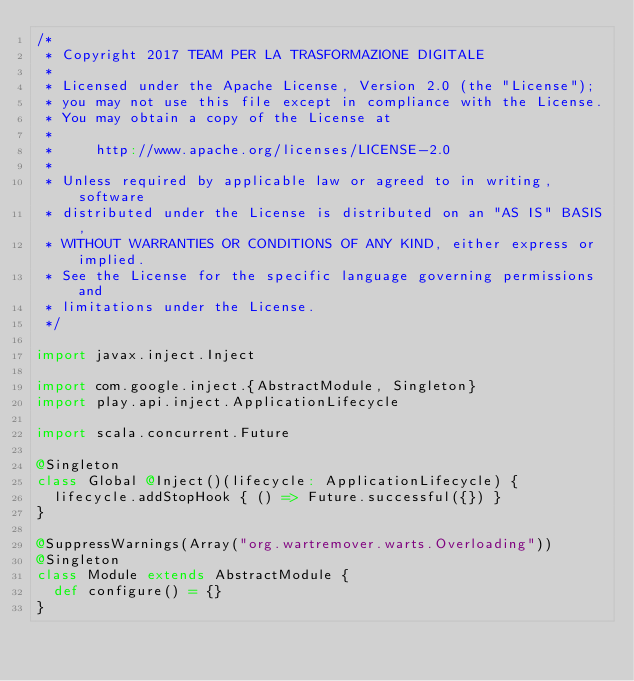Convert code to text. <code><loc_0><loc_0><loc_500><loc_500><_Scala_>/*
 * Copyright 2017 TEAM PER LA TRASFORMAZIONE DIGITALE
 *
 * Licensed under the Apache License, Version 2.0 (the "License");
 * you may not use this file except in compliance with the License.
 * You may obtain a copy of the License at
 *
 *     http://www.apache.org/licenses/LICENSE-2.0
 *
 * Unless required by applicable law or agreed to in writing, software
 * distributed under the License is distributed on an "AS IS" BASIS,
 * WITHOUT WARRANTIES OR CONDITIONS OF ANY KIND, either express or implied.
 * See the License for the specific language governing permissions and
 * limitations under the License.
 */

import javax.inject.Inject

import com.google.inject.{AbstractModule, Singleton}
import play.api.inject.ApplicationLifecycle

import scala.concurrent.Future

@Singleton
class Global @Inject()(lifecycle: ApplicationLifecycle) {
  lifecycle.addStopHook { () => Future.successful({}) }
}

@SuppressWarnings(Array("org.wartremover.warts.Overloading"))
@Singleton
class Module extends AbstractModule {
  def configure() = {}
}</code> 